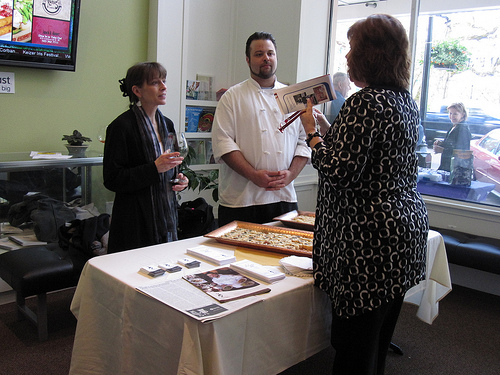<image>
Is there a man to the left of the woman? No. The man is not to the left of the woman. From this viewpoint, they have a different horizontal relationship. Is the woman one in front of the woman two? Yes. The woman one is positioned in front of the woman two, appearing closer to the camera viewpoint. Is there a women in front of the tv? Yes. The women is positioned in front of the tv, appearing closer to the camera viewpoint. 